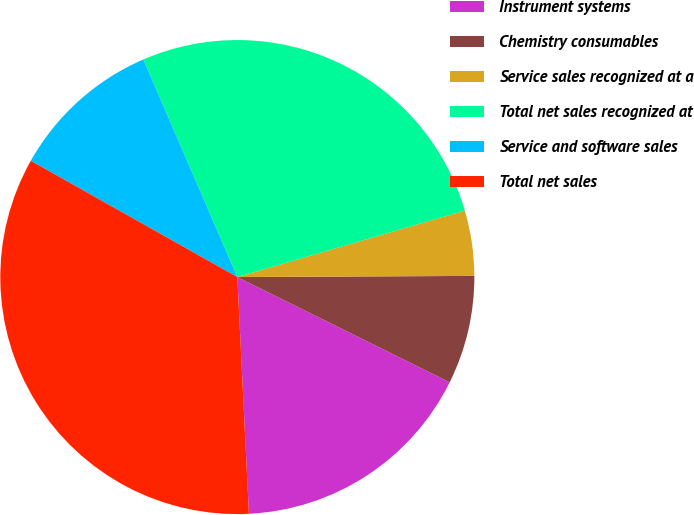Convert chart to OTSL. <chart><loc_0><loc_0><loc_500><loc_500><pie_chart><fcel>Instrument systems<fcel>Chemistry consumables<fcel>Service sales recognized at a<fcel>Total net sales recognized at<fcel>Service and software sales<fcel>Total net sales<nl><fcel>16.9%<fcel>7.4%<fcel>4.45%<fcel>26.96%<fcel>10.35%<fcel>33.94%<nl></chart> 